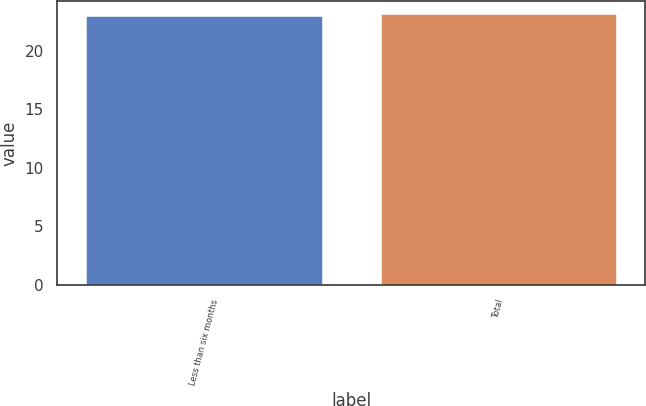Convert chart to OTSL. <chart><loc_0><loc_0><loc_500><loc_500><bar_chart><fcel>Less than six months<fcel>Total<nl><fcel>23<fcel>23.1<nl></chart> 